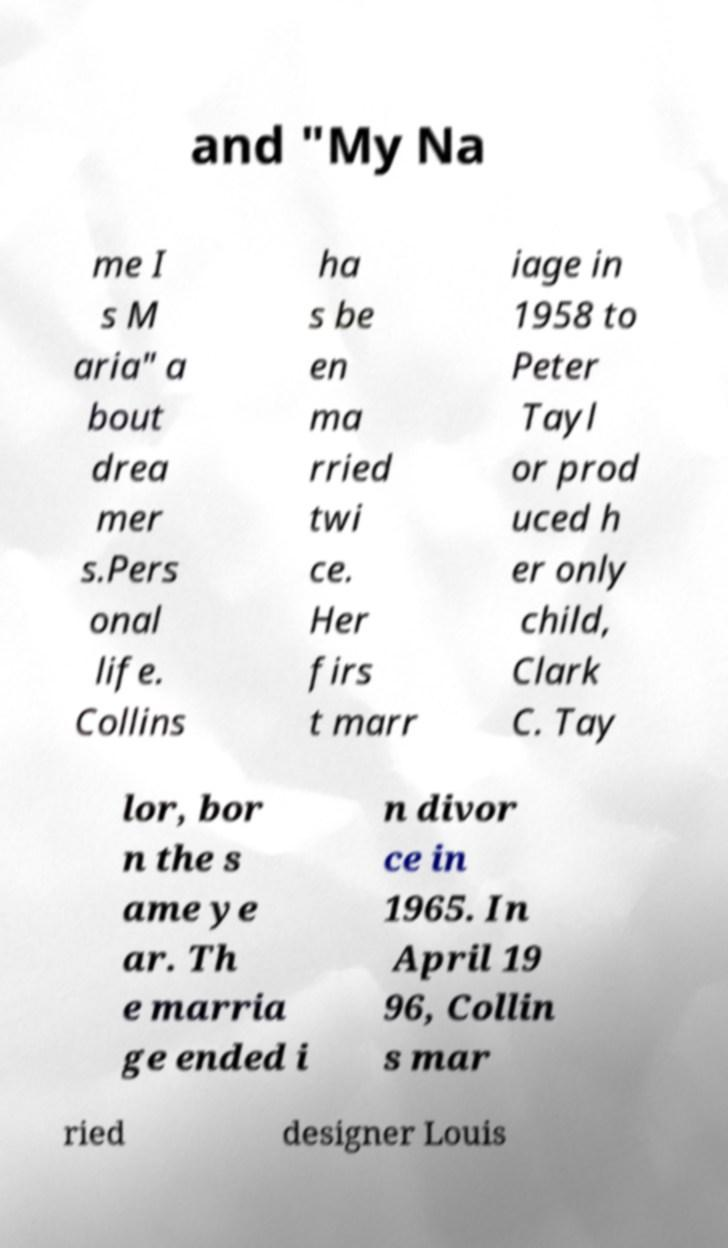Can you read and provide the text displayed in the image?This photo seems to have some interesting text. Can you extract and type it out for me? and "My Na me I s M aria" a bout drea mer s.Pers onal life. Collins ha s be en ma rried twi ce. Her firs t marr iage in 1958 to Peter Tayl or prod uced h er only child, Clark C. Tay lor, bor n the s ame ye ar. Th e marria ge ended i n divor ce in 1965. In April 19 96, Collin s mar ried designer Louis 